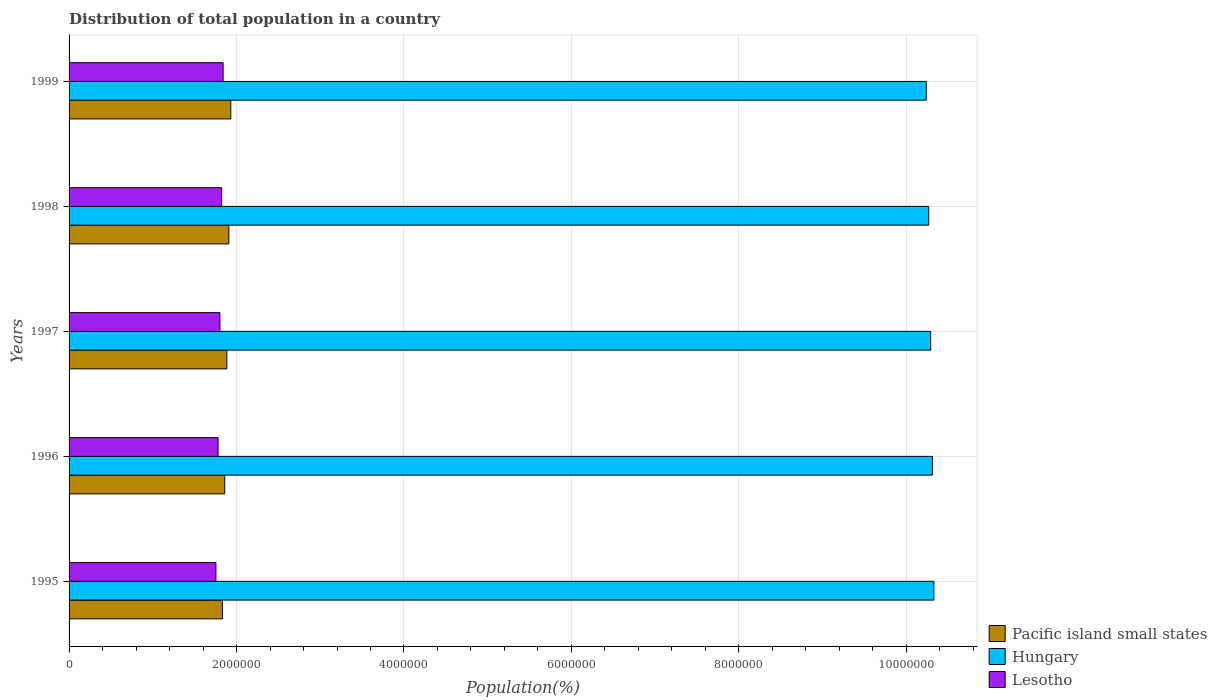How many groups of bars are there?
Ensure brevity in your answer.  5. Are the number of bars per tick equal to the number of legend labels?
Your response must be concise. Yes. How many bars are there on the 2nd tick from the bottom?
Provide a succinct answer. 3. In how many cases, is the number of bars for a given year not equal to the number of legend labels?
Offer a terse response. 0. What is the population of in Pacific island small states in 1999?
Provide a succinct answer. 1.93e+06. Across all years, what is the maximum population of in Hungary?
Provide a short and direct response. 1.03e+07. Across all years, what is the minimum population of in Pacific island small states?
Your response must be concise. 1.83e+06. In which year was the population of in Pacific island small states minimum?
Your answer should be very brief. 1995. What is the total population of in Pacific island small states in the graph?
Offer a very short reply. 9.41e+06. What is the difference between the population of in Hungary in 1995 and that in 1997?
Ensure brevity in your answer.  3.85e+04. What is the difference between the population of in Pacific island small states in 1997 and the population of in Lesotho in 1999?
Make the answer very short. 4.46e+04. What is the average population of in Lesotho per year?
Provide a short and direct response. 1.80e+06. In the year 1996, what is the difference between the population of in Pacific island small states and population of in Lesotho?
Ensure brevity in your answer.  7.96e+04. What is the ratio of the population of in Hungary in 1996 to that in 1998?
Your response must be concise. 1. Is the population of in Pacific island small states in 1996 less than that in 1999?
Your answer should be very brief. Yes. Is the difference between the population of in Pacific island small states in 1995 and 1999 greater than the difference between the population of in Lesotho in 1995 and 1999?
Your response must be concise. No. What is the difference between the highest and the second highest population of in Lesotho?
Provide a short and direct response. 1.80e+04. What is the difference between the highest and the lowest population of in Lesotho?
Provide a short and direct response. 8.58e+04. Is the sum of the population of in Lesotho in 1996 and 1997 greater than the maximum population of in Pacific island small states across all years?
Ensure brevity in your answer.  Yes. What does the 3rd bar from the top in 1995 represents?
Your response must be concise. Pacific island small states. What does the 3rd bar from the bottom in 1999 represents?
Give a very brief answer. Lesotho. How many bars are there?
Your response must be concise. 15. What is the difference between two consecutive major ticks on the X-axis?
Your response must be concise. 2.00e+06. Are the values on the major ticks of X-axis written in scientific E-notation?
Make the answer very short. No. Does the graph contain any zero values?
Your response must be concise. No. Where does the legend appear in the graph?
Offer a terse response. Bottom right. How many legend labels are there?
Your answer should be very brief. 3. What is the title of the graph?
Provide a succinct answer. Distribution of total population in a country. What is the label or title of the X-axis?
Offer a very short reply. Population(%). What is the label or title of the Y-axis?
Your answer should be very brief. Years. What is the Population(%) in Pacific island small states in 1995?
Give a very brief answer. 1.83e+06. What is the Population(%) in Hungary in 1995?
Provide a succinct answer. 1.03e+07. What is the Population(%) in Lesotho in 1995?
Make the answer very short. 1.75e+06. What is the Population(%) of Pacific island small states in 1996?
Provide a succinct answer. 1.86e+06. What is the Population(%) of Hungary in 1996?
Your response must be concise. 1.03e+07. What is the Population(%) of Lesotho in 1996?
Your answer should be compact. 1.78e+06. What is the Population(%) of Pacific island small states in 1997?
Give a very brief answer. 1.88e+06. What is the Population(%) in Hungary in 1997?
Your answer should be very brief. 1.03e+07. What is the Population(%) of Lesotho in 1997?
Offer a very short reply. 1.80e+06. What is the Population(%) of Pacific island small states in 1998?
Provide a succinct answer. 1.91e+06. What is the Population(%) in Hungary in 1998?
Ensure brevity in your answer.  1.03e+07. What is the Population(%) of Lesotho in 1998?
Your answer should be very brief. 1.82e+06. What is the Population(%) in Pacific island small states in 1999?
Your response must be concise. 1.93e+06. What is the Population(%) in Hungary in 1999?
Make the answer very short. 1.02e+07. What is the Population(%) in Lesotho in 1999?
Give a very brief answer. 1.84e+06. Across all years, what is the maximum Population(%) of Pacific island small states?
Offer a very short reply. 1.93e+06. Across all years, what is the maximum Population(%) of Hungary?
Your answer should be very brief. 1.03e+07. Across all years, what is the maximum Population(%) of Lesotho?
Your answer should be compact. 1.84e+06. Across all years, what is the minimum Population(%) of Pacific island small states?
Provide a short and direct response. 1.83e+06. Across all years, what is the minimum Population(%) of Hungary?
Provide a succinct answer. 1.02e+07. Across all years, what is the minimum Population(%) in Lesotho?
Make the answer very short. 1.75e+06. What is the total Population(%) of Pacific island small states in the graph?
Your answer should be compact. 9.41e+06. What is the total Population(%) of Hungary in the graph?
Provide a short and direct response. 5.14e+07. What is the total Population(%) of Lesotho in the graph?
Give a very brief answer. 9.00e+06. What is the difference between the Population(%) in Pacific island small states in 1995 and that in 1996?
Provide a short and direct response. -2.70e+04. What is the difference between the Population(%) of Hungary in 1995 and that in 1996?
Ensure brevity in your answer.  1.77e+04. What is the difference between the Population(%) of Lesotho in 1995 and that in 1996?
Keep it short and to the point. -2.54e+04. What is the difference between the Population(%) in Pacific island small states in 1995 and that in 1997?
Provide a short and direct response. -5.25e+04. What is the difference between the Population(%) of Hungary in 1995 and that in 1997?
Make the answer very short. 3.85e+04. What is the difference between the Population(%) in Lesotho in 1995 and that in 1997?
Keep it short and to the point. -4.79e+04. What is the difference between the Population(%) in Pacific island small states in 1995 and that in 1998?
Your answer should be compact. -7.66e+04. What is the difference between the Population(%) in Hungary in 1995 and that in 1998?
Give a very brief answer. 6.24e+04. What is the difference between the Population(%) of Lesotho in 1995 and that in 1998?
Provide a short and direct response. -6.78e+04. What is the difference between the Population(%) of Pacific island small states in 1995 and that in 1999?
Give a very brief answer. -9.96e+04. What is the difference between the Population(%) of Hungary in 1995 and that in 1999?
Offer a very short reply. 9.14e+04. What is the difference between the Population(%) in Lesotho in 1995 and that in 1999?
Your answer should be very brief. -8.58e+04. What is the difference between the Population(%) in Pacific island small states in 1996 and that in 1997?
Give a very brief answer. -2.55e+04. What is the difference between the Population(%) in Hungary in 1996 and that in 1997?
Provide a short and direct response. 2.08e+04. What is the difference between the Population(%) of Lesotho in 1996 and that in 1997?
Your answer should be very brief. -2.25e+04. What is the difference between the Population(%) in Pacific island small states in 1996 and that in 1998?
Your response must be concise. -4.96e+04. What is the difference between the Population(%) of Hungary in 1996 and that in 1998?
Keep it short and to the point. 4.47e+04. What is the difference between the Population(%) of Lesotho in 1996 and that in 1998?
Your answer should be compact. -4.24e+04. What is the difference between the Population(%) in Pacific island small states in 1996 and that in 1999?
Your answer should be very brief. -7.26e+04. What is the difference between the Population(%) of Hungary in 1996 and that in 1999?
Ensure brevity in your answer.  7.37e+04. What is the difference between the Population(%) in Lesotho in 1996 and that in 1999?
Give a very brief answer. -6.04e+04. What is the difference between the Population(%) in Pacific island small states in 1997 and that in 1998?
Provide a short and direct response. -2.41e+04. What is the difference between the Population(%) in Hungary in 1997 and that in 1998?
Offer a very short reply. 2.39e+04. What is the difference between the Population(%) in Lesotho in 1997 and that in 1998?
Make the answer very short. -1.99e+04. What is the difference between the Population(%) in Pacific island small states in 1997 and that in 1999?
Keep it short and to the point. -4.72e+04. What is the difference between the Population(%) of Hungary in 1997 and that in 1999?
Keep it short and to the point. 5.30e+04. What is the difference between the Population(%) in Lesotho in 1997 and that in 1999?
Offer a terse response. -3.79e+04. What is the difference between the Population(%) in Pacific island small states in 1998 and that in 1999?
Keep it short and to the point. -2.31e+04. What is the difference between the Population(%) in Hungary in 1998 and that in 1999?
Ensure brevity in your answer.  2.90e+04. What is the difference between the Population(%) of Lesotho in 1998 and that in 1999?
Provide a short and direct response. -1.80e+04. What is the difference between the Population(%) of Pacific island small states in 1995 and the Population(%) of Hungary in 1996?
Your response must be concise. -8.48e+06. What is the difference between the Population(%) of Pacific island small states in 1995 and the Population(%) of Lesotho in 1996?
Your answer should be compact. 5.26e+04. What is the difference between the Population(%) in Hungary in 1995 and the Population(%) in Lesotho in 1996?
Provide a short and direct response. 8.55e+06. What is the difference between the Population(%) of Pacific island small states in 1995 and the Population(%) of Hungary in 1997?
Make the answer very short. -8.46e+06. What is the difference between the Population(%) of Pacific island small states in 1995 and the Population(%) of Lesotho in 1997?
Ensure brevity in your answer.  3.01e+04. What is the difference between the Population(%) of Hungary in 1995 and the Population(%) of Lesotho in 1997?
Provide a short and direct response. 8.53e+06. What is the difference between the Population(%) of Pacific island small states in 1995 and the Population(%) of Hungary in 1998?
Ensure brevity in your answer.  -8.43e+06. What is the difference between the Population(%) of Pacific island small states in 1995 and the Population(%) of Lesotho in 1998?
Your answer should be compact. 1.02e+04. What is the difference between the Population(%) in Hungary in 1995 and the Population(%) in Lesotho in 1998?
Make the answer very short. 8.51e+06. What is the difference between the Population(%) of Pacific island small states in 1995 and the Population(%) of Hungary in 1999?
Your answer should be very brief. -8.41e+06. What is the difference between the Population(%) of Pacific island small states in 1995 and the Population(%) of Lesotho in 1999?
Keep it short and to the point. -7829. What is the difference between the Population(%) in Hungary in 1995 and the Population(%) in Lesotho in 1999?
Keep it short and to the point. 8.49e+06. What is the difference between the Population(%) in Pacific island small states in 1996 and the Population(%) in Hungary in 1997?
Offer a terse response. -8.43e+06. What is the difference between the Population(%) in Pacific island small states in 1996 and the Population(%) in Lesotho in 1997?
Make the answer very short. 5.71e+04. What is the difference between the Population(%) in Hungary in 1996 and the Population(%) in Lesotho in 1997?
Give a very brief answer. 8.51e+06. What is the difference between the Population(%) in Pacific island small states in 1996 and the Population(%) in Hungary in 1998?
Give a very brief answer. -8.41e+06. What is the difference between the Population(%) in Pacific island small states in 1996 and the Population(%) in Lesotho in 1998?
Offer a very short reply. 3.71e+04. What is the difference between the Population(%) of Hungary in 1996 and the Population(%) of Lesotho in 1998?
Your response must be concise. 8.49e+06. What is the difference between the Population(%) of Pacific island small states in 1996 and the Population(%) of Hungary in 1999?
Keep it short and to the point. -8.38e+06. What is the difference between the Population(%) of Pacific island small states in 1996 and the Population(%) of Lesotho in 1999?
Your answer should be very brief. 1.91e+04. What is the difference between the Population(%) of Hungary in 1996 and the Population(%) of Lesotho in 1999?
Your answer should be very brief. 8.47e+06. What is the difference between the Population(%) in Pacific island small states in 1997 and the Population(%) in Hungary in 1998?
Your answer should be very brief. -8.38e+06. What is the difference between the Population(%) in Pacific island small states in 1997 and the Population(%) in Lesotho in 1998?
Offer a terse response. 6.26e+04. What is the difference between the Population(%) in Hungary in 1997 and the Population(%) in Lesotho in 1998?
Your answer should be compact. 8.47e+06. What is the difference between the Population(%) of Pacific island small states in 1997 and the Population(%) of Hungary in 1999?
Provide a succinct answer. -8.35e+06. What is the difference between the Population(%) in Pacific island small states in 1997 and the Population(%) in Lesotho in 1999?
Ensure brevity in your answer.  4.46e+04. What is the difference between the Population(%) of Hungary in 1997 and the Population(%) of Lesotho in 1999?
Ensure brevity in your answer.  8.45e+06. What is the difference between the Population(%) of Pacific island small states in 1998 and the Population(%) of Hungary in 1999?
Provide a succinct answer. -8.33e+06. What is the difference between the Population(%) in Pacific island small states in 1998 and the Population(%) in Lesotho in 1999?
Offer a terse response. 6.87e+04. What is the difference between the Population(%) in Hungary in 1998 and the Population(%) in Lesotho in 1999?
Provide a short and direct response. 8.43e+06. What is the average Population(%) of Pacific island small states per year?
Ensure brevity in your answer.  1.88e+06. What is the average Population(%) in Hungary per year?
Provide a succinct answer. 1.03e+07. What is the average Population(%) in Lesotho per year?
Ensure brevity in your answer.  1.80e+06. In the year 1995, what is the difference between the Population(%) in Pacific island small states and Population(%) in Hungary?
Your answer should be compact. -8.50e+06. In the year 1995, what is the difference between the Population(%) of Pacific island small states and Population(%) of Lesotho?
Ensure brevity in your answer.  7.80e+04. In the year 1995, what is the difference between the Population(%) of Hungary and Population(%) of Lesotho?
Keep it short and to the point. 8.58e+06. In the year 1996, what is the difference between the Population(%) in Pacific island small states and Population(%) in Hungary?
Give a very brief answer. -8.45e+06. In the year 1996, what is the difference between the Population(%) in Pacific island small states and Population(%) in Lesotho?
Your response must be concise. 7.96e+04. In the year 1996, what is the difference between the Population(%) in Hungary and Population(%) in Lesotho?
Make the answer very short. 8.53e+06. In the year 1997, what is the difference between the Population(%) in Pacific island small states and Population(%) in Hungary?
Your answer should be compact. -8.41e+06. In the year 1997, what is the difference between the Population(%) of Pacific island small states and Population(%) of Lesotho?
Make the answer very short. 8.26e+04. In the year 1997, what is the difference between the Population(%) in Hungary and Population(%) in Lesotho?
Your response must be concise. 8.49e+06. In the year 1998, what is the difference between the Population(%) of Pacific island small states and Population(%) of Hungary?
Your answer should be very brief. -8.36e+06. In the year 1998, what is the difference between the Population(%) of Pacific island small states and Population(%) of Lesotho?
Your answer should be very brief. 8.67e+04. In the year 1998, what is the difference between the Population(%) in Hungary and Population(%) in Lesotho?
Offer a terse response. 8.44e+06. In the year 1999, what is the difference between the Population(%) of Pacific island small states and Population(%) of Hungary?
Your answer should be compact. -8.31e+06. In the year 1999, what is the difference between the Population(%) in Pacific island small states and Population(%) in Lesotho?
Provide a short and direct response. 9.18e+04. In the year 1999, what is the difference between the Population(%) of Hungary and Population(%) of Lesotho?
Ensure brevity in your answer.  8.40e+06. What is the ratio of the Population(%) of Pacific island small states in 1995 to that in 1996?
Offer a very short reply. 0.99. What is the ratio of the Population(%) in Lesotho in 1995 to that in 1996?
Offer a terse response. 0.99. What is the ratio of the Population(%) in Pacific island small states in 1995 to that in 1997?
Provide a short and direct response. 0.97. What is the ratio of the Population(%) of Lesotho in 1995 to that in 1997?
Your response must be concise. 0.97. What is the ratio of the Population(%) of Pacific island small states in 1995 to that in 1998?
Your answer should be compact. 0.96. What is the ratio of the Population(%) of Lesotho in 1995 to that in 1998?
Your response must be concise. 0.96. What is the ratio of the Population(%) in Pacific island small states in 1995 to that in 1999?
Your answer should be very brief. 0.95. What is the ratio of the Population(%) of Hungary in 1995 to that in 1999?
Provide a short and direct response. 1.01. What is the ratio of the Population(%) of Lesotho in 1995 to that in 1999?
Your response must be concise. 0.95. What is the ratio of the Population(%) of Pacific island small states in 1996 to that in 1997?
Provide a short and direct response. 0.99. What is the ratio of the Population(%) in Hungary in 1996 to that in 1997?
Your answer should be very brief. 1. What is the ratio of the Population(%) of Lesotho in 1996 to that in 1997?
Offer a very short reply. 0.99. What is the ratio of the Population(%) in Pacific island small states in 1996 to that in 1998?
Offer a very short reply. 0.97. What is the ratio of the Population(%) of Hungary in 1996 to that in 1998?
Offer a very short reply. 1. What is the ratio of the Population(%) in Lesotho in 1996 to that in 1998?
Ensure brevity in your answer.  0.98. What is the ratio of the Population(%) of Pacific island small states in 1996 to that in 1999?
Your response must be concise. 0.96. What is the ratio of the Population(%) in Lesotho in 1996 to that in 1999?
Your response must be concise. 0.97. What is the ratio of the Population(%) in Pacific island small states in 1997 to that in 1998?
Your answer should be compact. 0.99. What is the ratio of the Population(%) of Hungary in 1997 to that in 1998?
Provide a short and direct response. 1. What is the ratio of the Population(%) of Lesotho in 1997 to that in 1998?
Your answer should be compact. 0.99. What is the ratio of the Population(%) of Pacific island small states in 1997 to that in 1999?
Make the answer very short. 0.98. What is the ratio of the Population(%) of Lesotho in 1997 to that in 1999?
Offer a terse response. 0.98. What is the ratio of the Population(%) of Pacific island small states in 1998 to that in 1999?
Your answer should be compact. 0.99. What is the ratio of the Population(%) in Lesotho in 1998 to that in 1999?
Your answer should be compact. 0.99. What is the difference between the highest and the second highest Population(%) of Pacific island small states?
Offer a terse response. 2.31e+04. What is the difference between the highest and the second highest Population(%) in Hungary?
Offer a terse response. 1.77e+04. What is the difference between the highest and the second highest Population(%) in Lesotho?
Your response must be concise. 1.80e+04. What is the difference between the highest and the lowest Population(%) of Pacific island small states?
Your answer should be compact. 9.96e+04. What is the difference between the highest and the lowest Population(%) in Hungary?
Keep it short and to the point. 9.14e+04. What is the difference between the highest and the lowest Population(%) in Lesotho?
Give a very brief answer. 8.58e+04. 